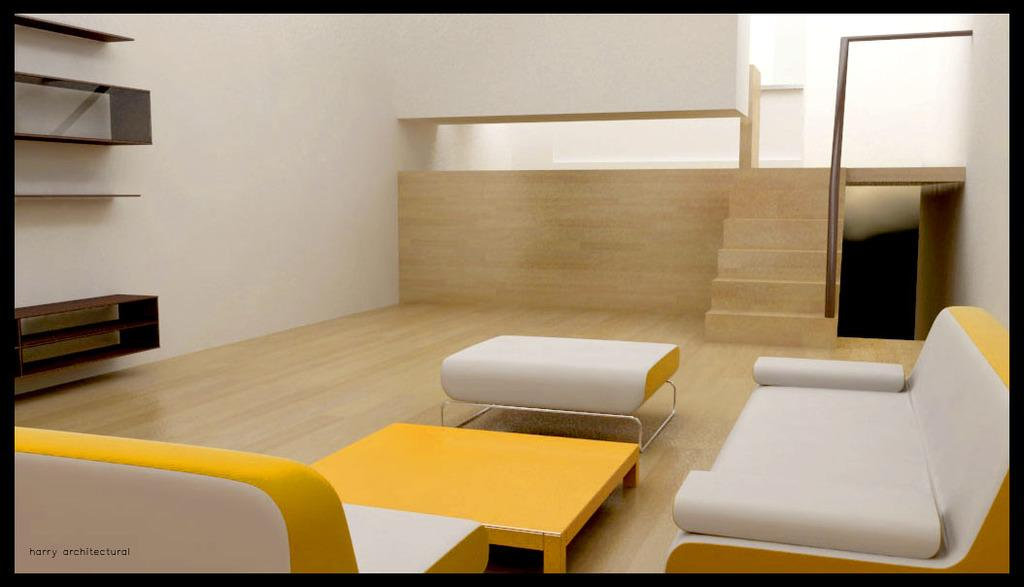What type of furniture is present in the image? There are sofas and a table in the image. What other type of furniture can be seen on the wall? There is a cupboard on the wall in the image. What architectural feature is visible in the background of the image? There is a staircase with a railing in the background of the image. Where is the bomb hidden in the image? There is no bomb present in the image. What type of tent can be seen in the image? There is no tent present in the image. 